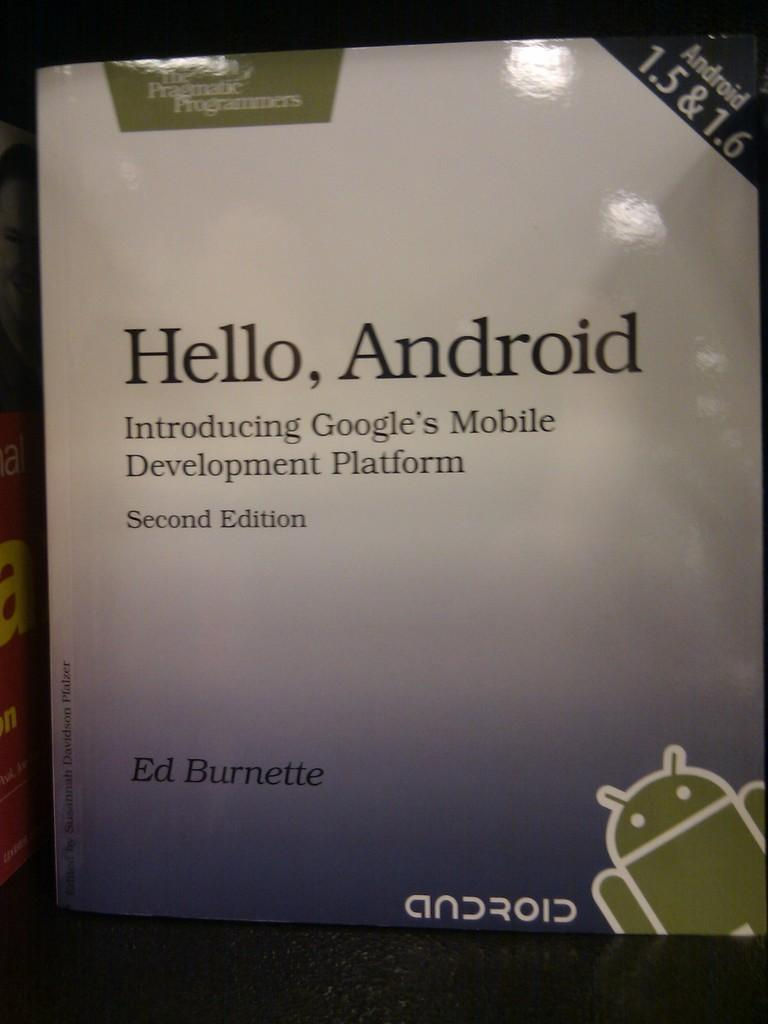<image>
Render a clear and concise summary of the photo. A reference book on computer programming is called Hello, Android. 